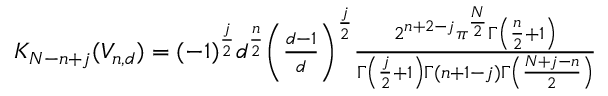Convert formula to latex. <formula><loc_0><loc_0><loc_500><loc_500>\begin{array} { r } { K _ { N - n + j } ( { V } _ { n , d } ) = ( - 1 ) ^ { \frac { j } { 2 } } d ^ { \frac { n } { 2 } } \left ( \frac { d - 1 } { d } \right ) ^ { \frac { j } { 2 } } \frac { 2 ^ { n + 2 - j } \pi ^ { \frac { N } { 2 } } \Gamma \left ( \frac { n } { 2 } + 1 \right ) } { \Gamma \left ( \frac { j } { 2 } + 1 \right ) \Gamma ( n + 1 - j ) \Gamma \left ( \frac { N + j - n } { 2 } \right ) } } \end{array}</formula> 